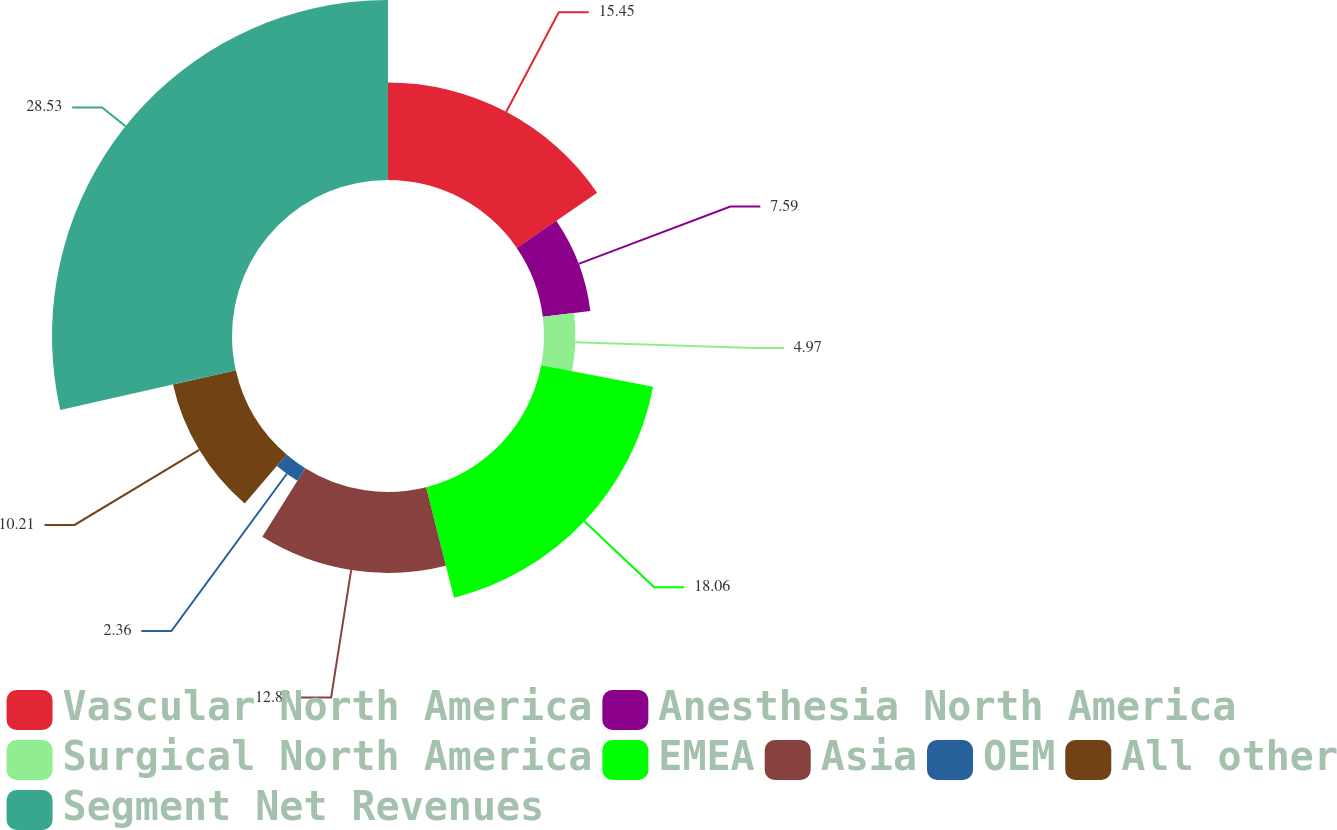Convert chart to OTSL. <chart><loc_0><loc_0><loc_500><loc_500><pie_chart><fcel>Vascular North America<fcel>Anesthesia North America<fcel>Surgical North America<fcel>EMEA<fcel>Asia<fcel>OEM<fcel>All other<fcel>Segment Net Revenues<nl><fcel>15.45%<fcel>7.59%<fcel>4.97%<fcel>18.06%<fcel>12.83%<fcel>2.36%<fcel>10.21%<fcel>28.53%<nl></chart> 